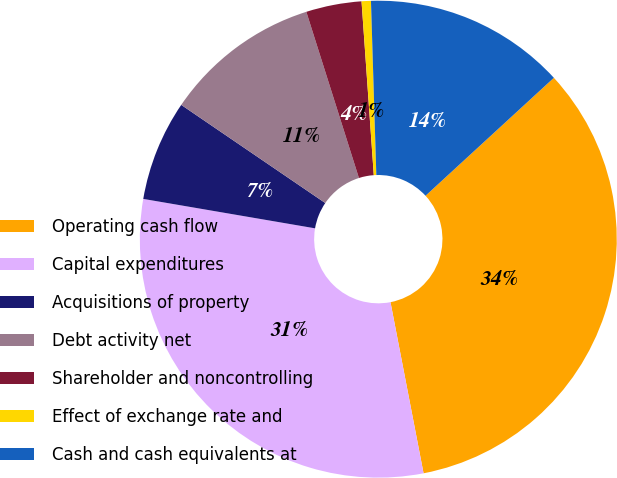Convert chart. <chart><loc_0><loc_0><loc_500><loc_500><pie_chart><fcel>Operating cash flow<fcel>Capital expenditures<fcel>Acquisitions of property<fcel>Debt activity net<fcel>Shareholder and noncontrolling<fcel>Effect of exchange rate and<fcel>Cash and cash equivalents at<nl><fcel>33.79%<fcel>30.74%<fcel>6.82%<fcel>10.6%<fcel>3.76%<fcel>0.63%<fcel>13.66%<nl></chart> 